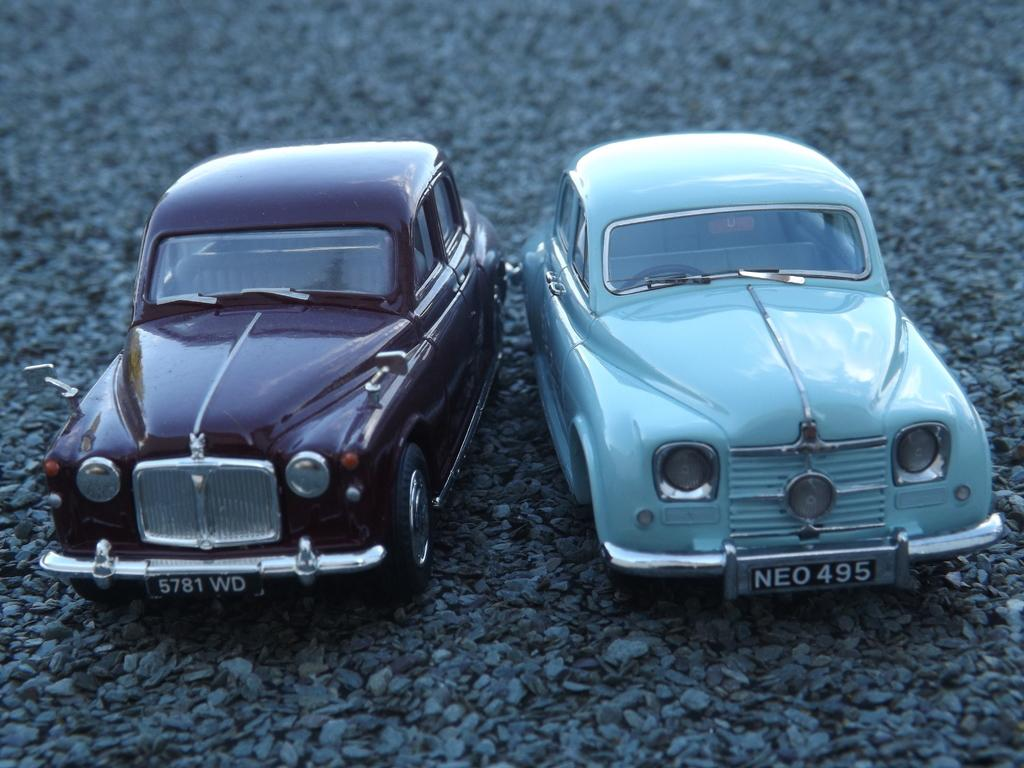How many cars are present in the image? There are two cars in the image. Where are the cars located? The cars are on the land in the image. What type of surface is the land covered with? There is stone gravel on the land in the image. What type of spring can be seen connecting the two cars in the image? There is no spring connecting the two cars in the image; they are simply located on the land. How does the rainstorm affect the visibility of the cars in the image? There is no rainstorm present in the image, so its effect on the visibility of the cars cannot be determined. 